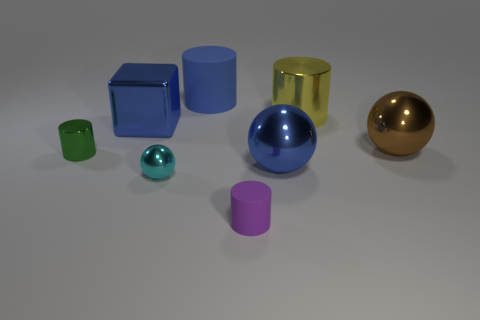Could you describe the lighting and shadows in the scene? There is a soft, diffuse light source illuminating the scene from the top-left, creating gentle shadows on the right side of the objects, suggesting the light source is not directly overhead but slightly to the side. 